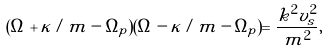Convert formula to latex. <formula><loc_0><loc_0><loc_500><loc_500>( \Omega + \kappa / m - \Omega _ { p } ) ( \Omega - \kappa / m - \Omega _ { p } ) = \frac { k ^ { 2 } v _ { s } ^ { 2 } } { m ^ { 2 } } ,</formula> 